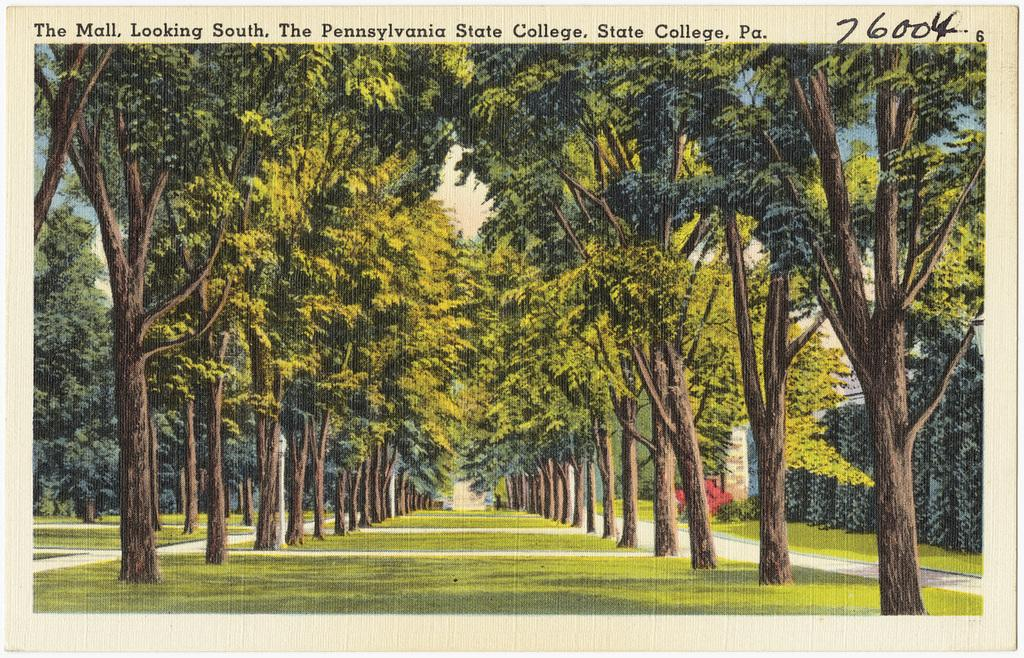What type of surface is visible in the image? There is a grassy ground in the image. What feature is present on the grassy ground? There is a walking path on the ground. What can be seen around the walking path? The walking path is surrounded by trees. What type of sugar is being used to treat the patient in the image? There is no patient or sugar present in the image; it features a grassy ground with a walking path surrounded by trees. 